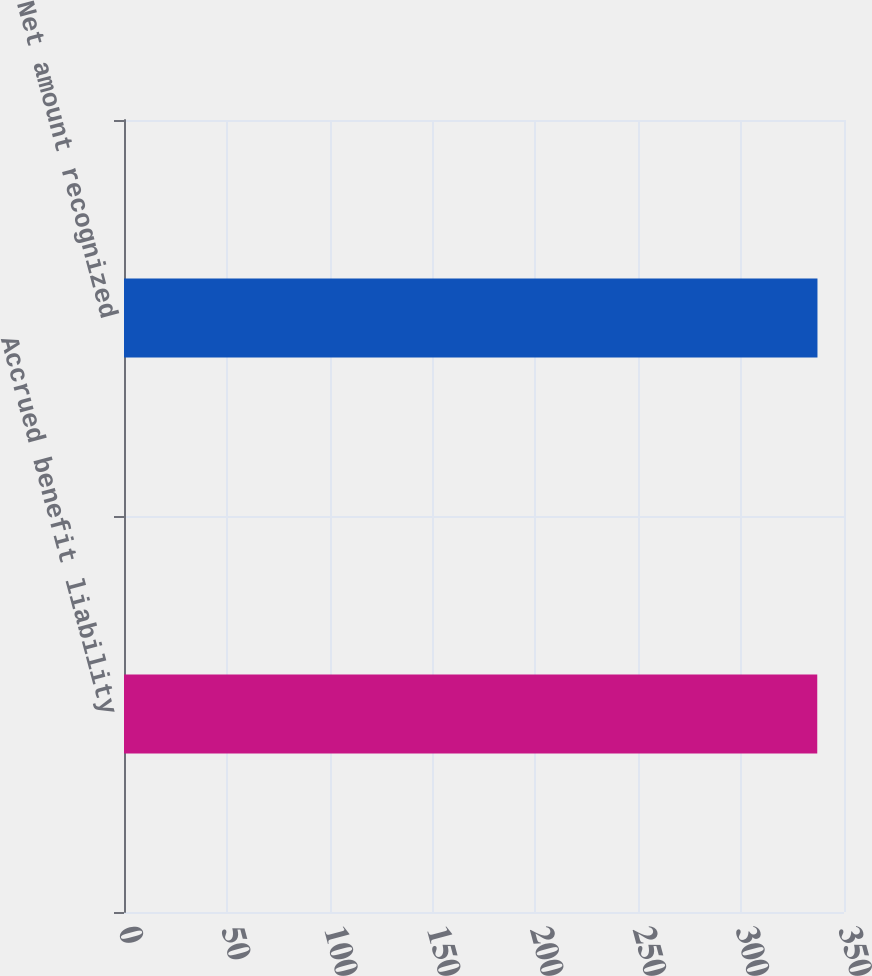<chart> <loc_0><loc_0><loc_500><loc_500><bar_chart><fcel>Accrued benefit liability<fcel>Net amount recognized<nl><fcel>337<fcel>337.1<nl></chart> 